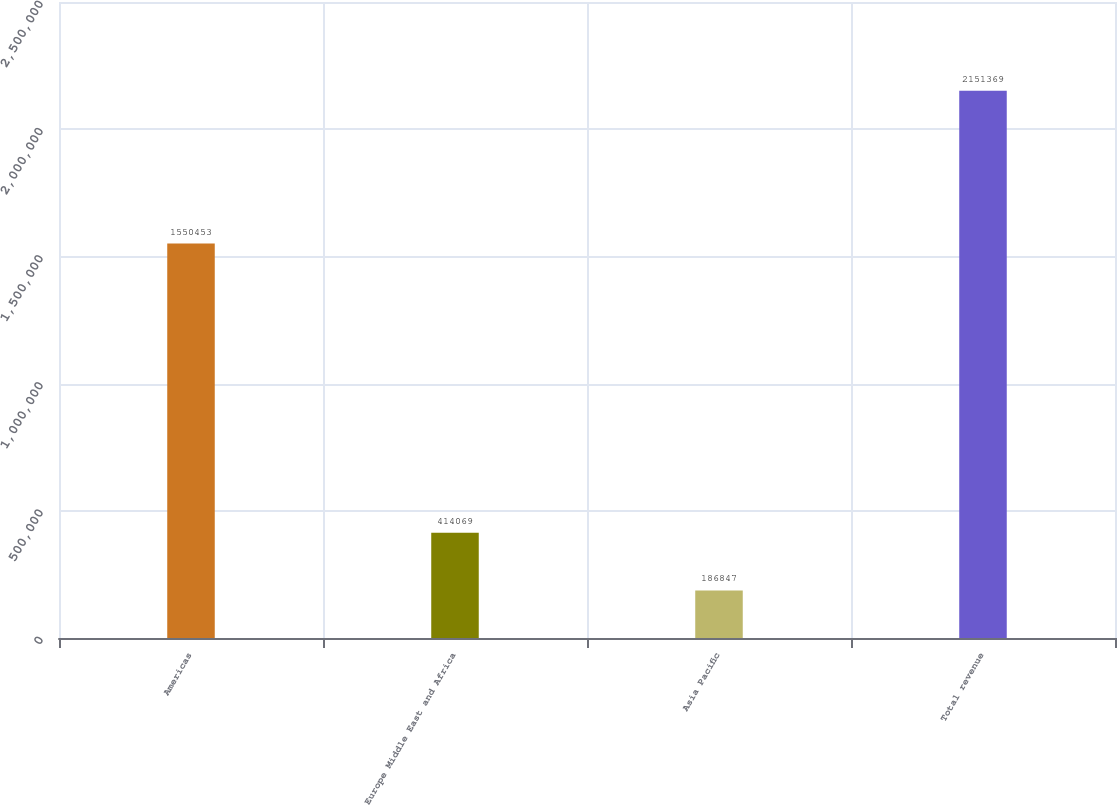Convert chart to OTSL. <chart><loc_0><loc_0><loc_500><loc_500><bar_chart><fcel>Americas<fcel>Europe Middle East and Africa<fcel>Asia Pacific<fcel>Total revenue<nl><fcel>1.55045e+06<fcel>414069<fcel>186847<fcel>2.15137e+06<nl></chart> 